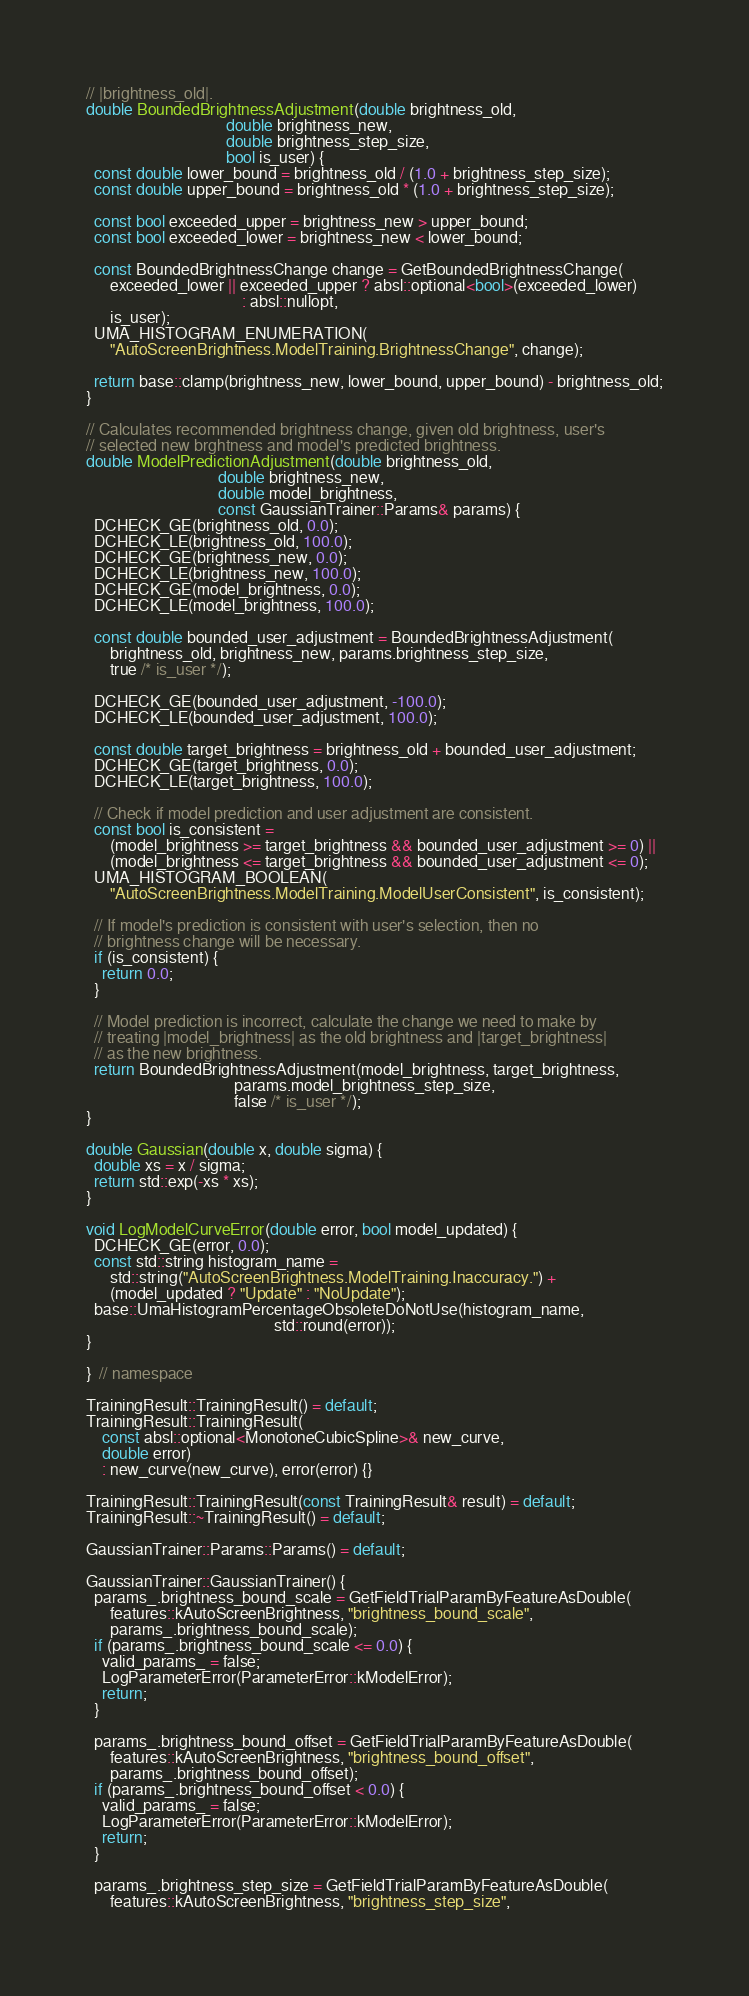<code> <loc_0><loc_0><loc_500><loc_500><_C++_>// |brightness_old|.
double BoundedBrightnessAdjustment(double brightness_old,
                                   double brightness_new,
                                   double brightness_step_size,
                                   bool is_user) {
  const double lower_bound = brightness_old / (1.0 + brightness_step_size);
  const double upper_bound = brightness_old * (1.0 + brightness_step_size);

  const bool exceeded_upper = brightness_new > upper_bound;
  const bool exceeded_lower = brightness_new < lower_bound;

  const BoundedBrightnessChange change = GetBoundedBrightnessChange(
      exceeded_lower || exceeded_upper ? absl::optional<bool>(exceeded_lower)
                                       : absl::nullopt,
      is_user);
  UMA_HISTOGRAM_ENUMERATION(
      "AutoScreenBrightness.ModelTraining.BrightnessChange", change);

  return base::clamp(brightness_new, lower_bound, upper_bound) - brightness_old;
}

// Calculates recommended brightness change, given old brightness, user's
// selected new brghtness and model's predicted brightness.
double ModelPredictionAdjustment(double brightness_old,
                                 double brightness_new,
                                 double model_brightness,
                                 const GaussianTrainer::Params& params) {
  DCHECK_GE(brightness_old, 0.0);
  DCHECK_LE(brightness_old, 100.0);
  DCHECK_GE(brightness_new, 0.0);
  DCHECK_LE(brightness_new, 100.0);
  DCHECK_GE(model_brightness, 0.0);
  DCHECK_LE(model_brightness, 100.0);

  const double bounded_user_adjustment = BoundedBrightnessAdjustment(
      brightness_old, brightness_new, params.brightness_step_size,
      true /* is_user */);

  DCHECK_GE(bounded_user_adjustment, -100.0);
  DCHECK_LE(bounded_user_adjustment, 100.0);

  const double target_brightness = brightness_old + bounded_user_adjustment;
  DCHECK_GE(target_brightness, 0.0);
  DCHECK_LE(target_brightness, 100.0);

  // Check if model prediction and user adjustment are consistent.
  const bool is_consistent =
      (model_brightness >= target_brightness && bounded_user_adjustment >= 0) ||
      (model_brightness <= target_brightness && bounded_user_adjustment <= 0);
  UMA_HISTOGRAM_BOOLEAN(
      "AutoScreenBrightness.ModelTraining.ModelUserConsistent", is_consistent);

  // If model's prediction is consistent with user's selection, then no
  // brightness change will be necessary.
  if (is_consistent) {
    return 0.0;
  }

  // Model prediction is incorrect, calculate the change we need to make by
  // treating |model_brightness| as the old brightness and |target_brightness|
  // as the new brightness.
  return BoundedBrightnessAdjustment(model_brightness, target_brightness,
                                     params.model_brightness_step_size,
                                     false /* is_user */);
}

double Gaussian(double x, double sigma) {
  double xs = x / sigma;
  return std::exp(-xs * xs);
}

void LogModelCurveError(double error, bool model_updated) {
  DCHECK_GE(error, 0.0);
  const std::string histogram_name =
      std::string("AutoScreenBrightness.ModelTraining.Inaccuracy.") +
      (model_updated ? "Update" : "NoUpdate");
  base::UmaHistogramPercentageObsoleteDoNotUse(histogram_name,
                                               std::round(error));
}

}  // namespace

TrainingResult::TrainingResult() = default;
TrainingResult::TrainingResult(
    const absl::optional<MonotoneCubicSpline>& new_curve,
    double error)
    : new_curve(new_curve), error(error) {}

TrainingResult::TrainingResult(const TrainingResult& result) = default;
TrainingResult::~TrainingResult() = default;

GaussianTrainer::Params::Params() = default;

GaussianTrainer::GaussianTrainer() {
  params_.brightness_bound_scale = GetFieldTrialParamByFeatureAsDouble(
      features::kAutoScreenBrightness, "brightness_bound_scale",
      params_.brightness_bound_scale);
  if (params_.brightness_bound_scale <= 0.0) {
    valid_params_ = false;
    LogParameterError(ParameterError::kModelError);
    return;
  }

  params_.brightness_bound_offset = GetFieldTrialParamByFeatureAsDouble(
      features::kAutoScreenBrightness, "brightness_bound_offset",
      params_.brightness_bound_offset);
  if (params_.brightness_bound_offset < 0.0) {
    valid_params_ = false;
    LogParameterError(ParameterError::kModelError);
    return;
  }

  params_.brightness_step_size = GetFieldTrialParamByFeatureAsDouble(
      features::kAutoScreenBrightness, "brightness_step_size",</code> 